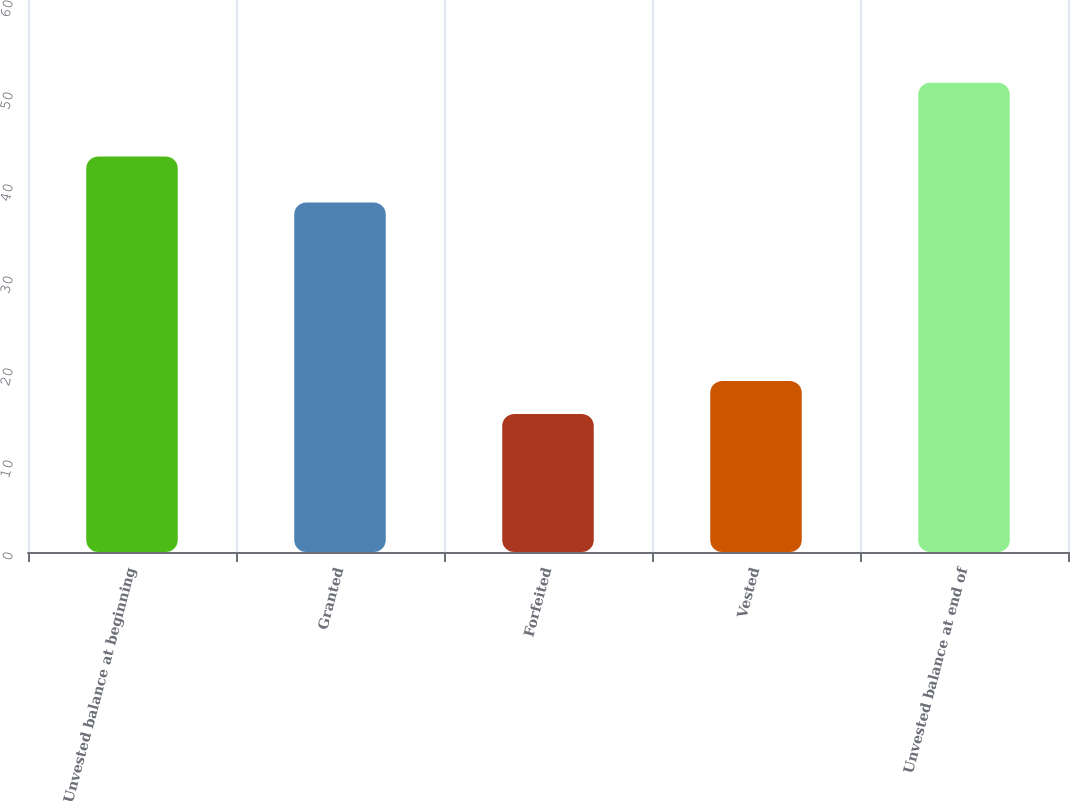Convert chart to OTSL. <chart><loc_0><loc_0><loc_500><loc_500><bar_chart><fcel>Unvested balance at beginning<fcel>Granted<fcel>Forfeited<fcel>Vested<fcel>Unvested balance at end of<nl><fcel>43<fcel>38<fcel>15<fcel>18.6<fcel>51<nl></chart> 